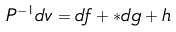Convert formula to latex. <formula><loc_0><loc_0><loc_500><loc_500>P ^ { - 1 } d v = d f + * d g + h</formula> 